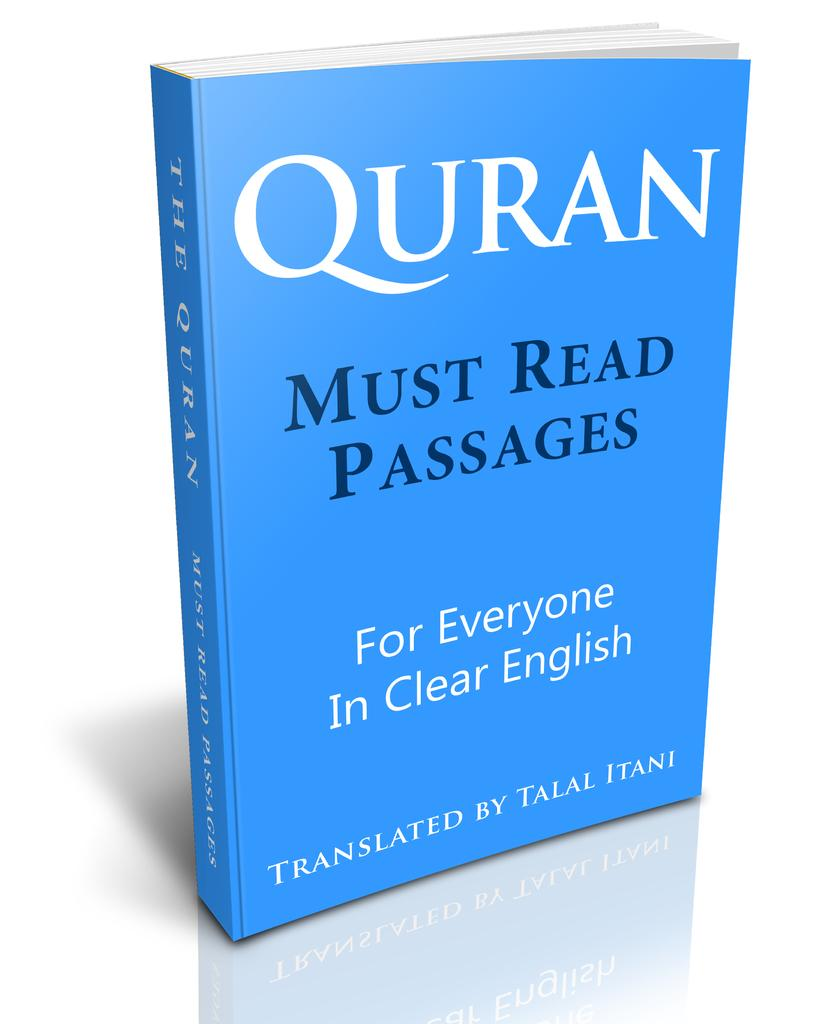<image>
Present a compact description of the photo's key features. A blue book titled Quran with the sentence must read passages written under the title is displayed with a plain, white background. 